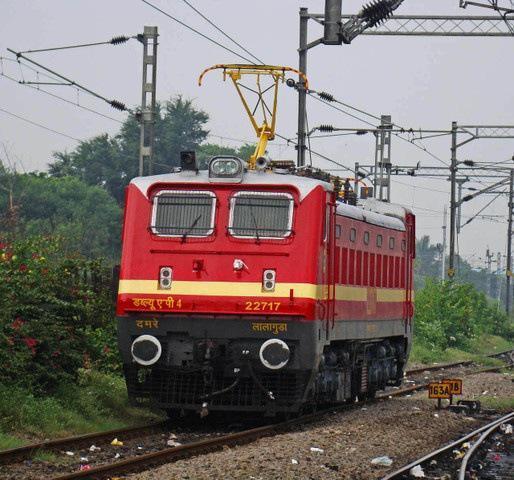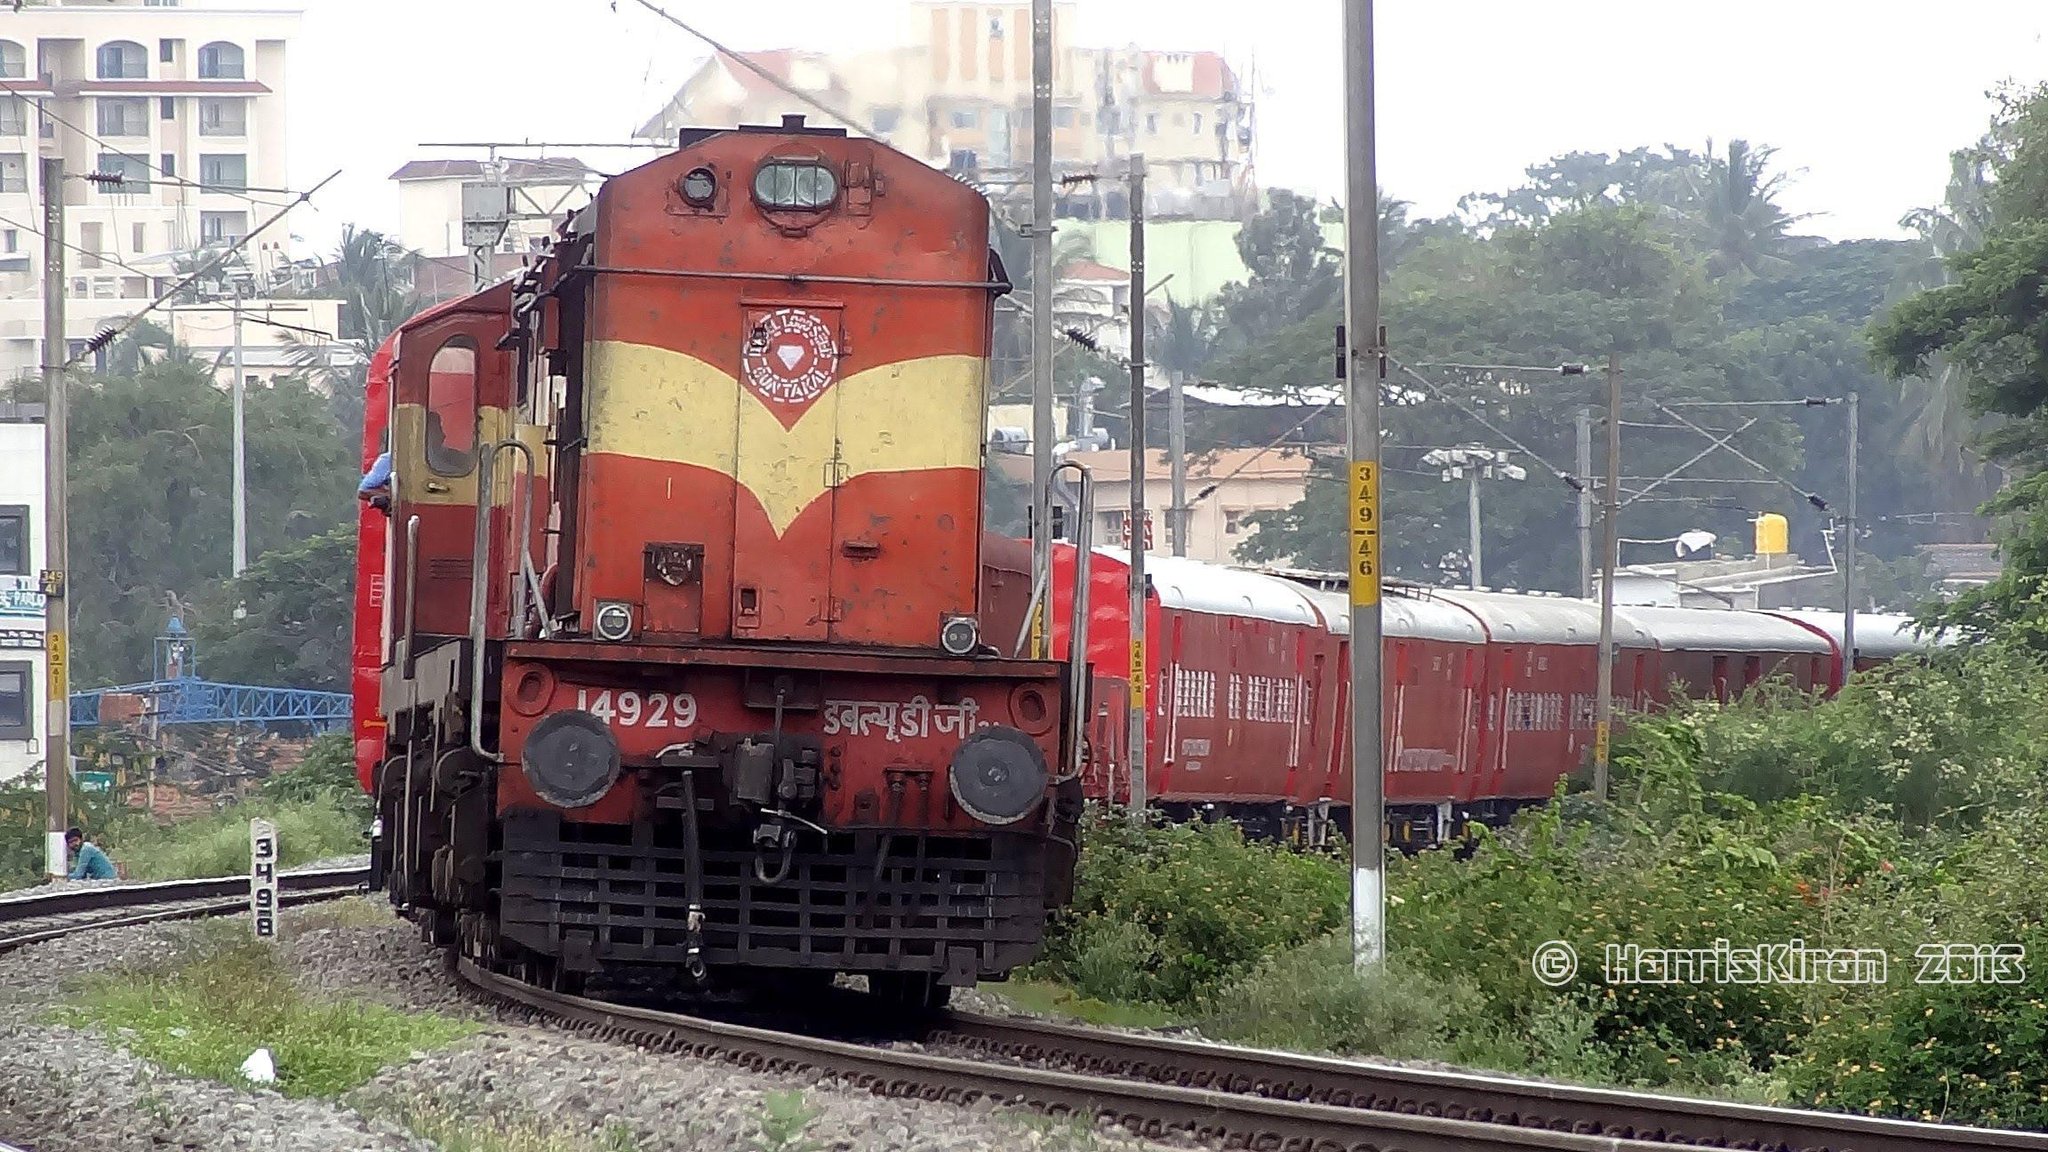The first image is the image on the left, the second image is the image on the right. Considering the images on both sides, is "A train in one image is red with two grated windows on the front and a narrow yellow band encircling the car." valid? Answer yes or no. Yes. 